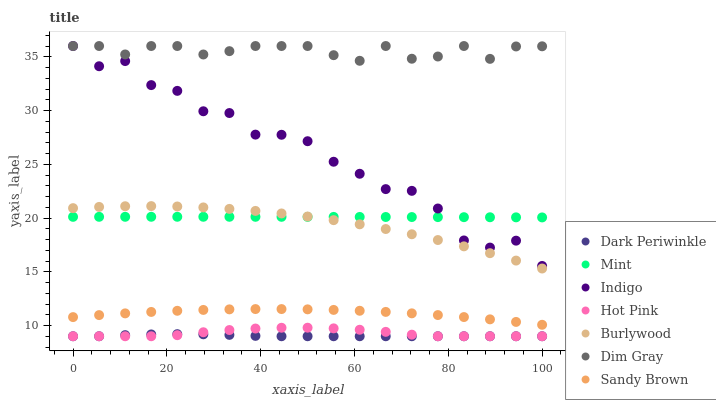Does Dark Periwinkle have the minimum area under the curve?
Answer yes or no. Yes. Does Dim Gray have the maximum area under the curve?
Answer yes or no. Yes. Does Indigo have the minimum area under the curve?
Answer yes or no. No. Does Indigo have the maximum area under the curve?
Answer yes or no. No. Is Mint the smoothest?
Answer yes or no. Yes. Is Indigo the roughest?
Answer yes or no. Yes. Is Burlywood the smoothest?
Answer yes or no. No. Is Burlywood the roughest?
Answer yes or no. No. Does Hot Pink have the lowest value?
Answer yes or no. Yes. Does Indigo have the lowest value?
Answer yes or no. No. Does Indigo have the highest value?
Answer yes or no. Yes. Does Burlywood have the highest value?
Answer yes or no. No. Is Dark Periwinkle less than Dim Gray?
Answer yes or no. Yes. Is Dim Gray greater than Dark Periwinkle?
Answer yes or no. Yes. Does Indigo intersect Dim Gray?
Answer yes or no. Yes. Is Indigo less than Dim Gray?
Answer yes or no. No. Is Indigo greater than Dim Gray?
Answer yes or no. No. Does Dark Periwinkle intersect Dim Gray?
Answer yes or no. No. 